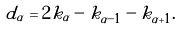<formula> <loc_0><loc_0><loc_500><loc_500>d _ { \alpha } = 2 k _ { \alpha } - k _ { \alpha - 1 } - k _ { \alpha + 1 } .</formula> 